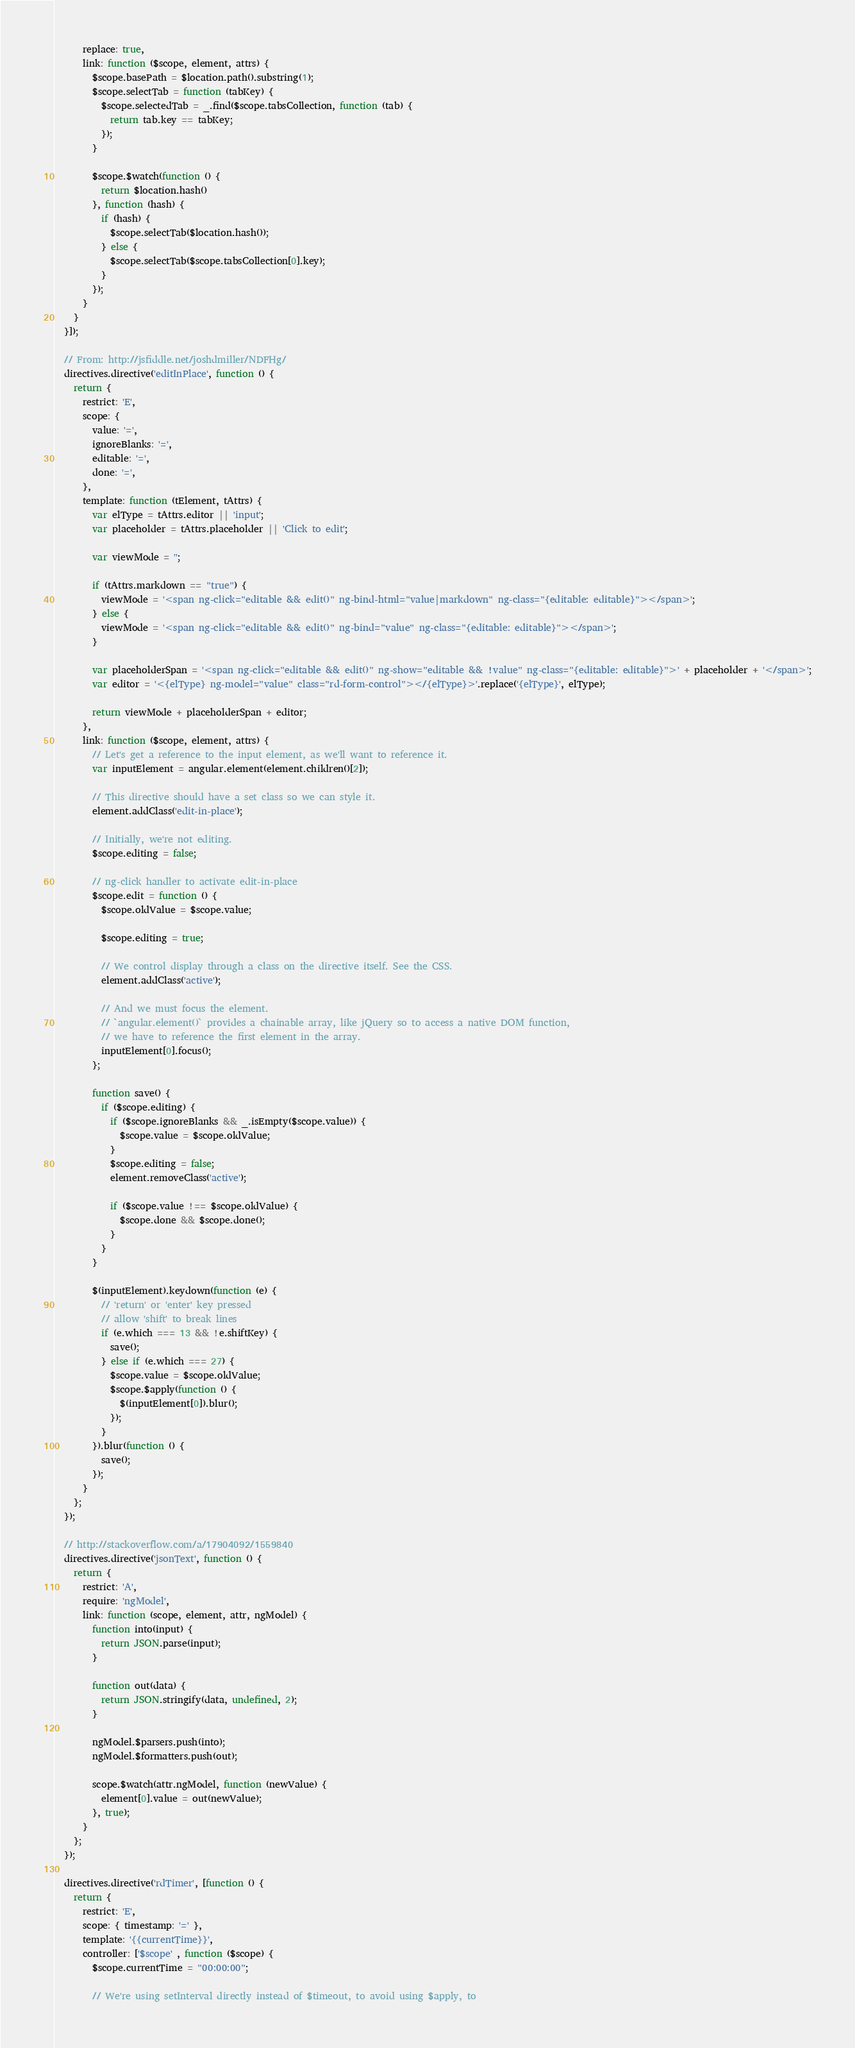<code> <loc_0><loc_0><loc_500><loc_500><_JavaScript_>      replace: true,
      link: function ($scope, element, attrs) {
        $scope.basePath = $location.path().substring(1);
        $scope.selectTab = function (tabKey) {
          $scope.selectedTab = _.find($scope.tabsCollection, function (tab) {
            return tab.key == tabKey;
          });
        }

        $scope.$watch(function () {
          return $location.hash()
        }, function (hash) {
          if (hash) {
            $scope.selectTab($location.hash());
          } else {
            $scope.selectTab($scope.tabsCollection[0].key);
          }
        });
      }
    }
  }]);

  // From: http://jsfiddle.net/joshdmiller/NDFHg/
  directives.directive('editInPlace', function () {
    return {
      restrict: 'E',
      scope: {
        value: '=',
        ignoreBlanks: '=',
        editable: '=',
        done: '=',
      },
      template: function (tElement, tAttrs) {
        var elType = tAttrs.editor || 'input';
        var placeholder = tAttrs.placeholder || 'Click to edit';

        var viewMode = '';

        if (tAttrs.markdown == "true") {
          viewMode = '<span ng-click="editable && edit()" ng-bind-html="value|markdown" ng-class="{editable: editable}"></span>';
        } else {
          viewMode = '<span ng-click="editable && edit()" ng-bind="value" ng-class="{editable: editable}"></span>';
        }

        var placeholderSpan = '<span ng-click="editable && edit()" ng-show="editable && !value" ng-class="{editable: editable}">' + placeholder + '</span>';
        var editor = '<{elType} ng-model="value" class="rd-form-control"></{elType}>'.replace('{elType}', elType);

        return viewMode + placeholderSpan + editor;
      },
      link: function ($scope, element, attrs) {
        // Let's get a reference to the input element, as we'll want to reference it.
        var inputElement = angular.element(element.children()[2]);

        // This directive should have a set class so we can style it.
        element.addClass('edit-in-place');

        // Initially, we're not editing.
        $scope.editing = false;

        // ng-click handler to activate edit-in-place
        $scope.edit = function () {
          $scope.oldValue = $scope.value;

          $scope.editing = true;

          // We control display through a class on the directive itself. See the CSS.
          element.addClass('active');

          // And we must focus the element.
          // `angular.element()` provides a chainable array, like jQuery so to access a native DOM function,
          // we have to reference the first element in the array.
          inputElement[0].focus();
        };

        function save() {
          if ($scope.editing) {
            if ($scope.ignoreBlanks && _.isEmpty($scope.value)) {
              $scope.value = $scope.oldValue;
            }
            $scope.editing = false;
            element.removeClass('active');

            if ($scope.value !== $scope.oldValue) {
              $scope.done && $scope.done();
            }
          }
        }

        $(inputElement).keydown(function (e) {
          // 'return' or 'enter' key pressed
          // allow 'shift' to break lines
          if (e.which === 13 && !e.shiftKey) {
            save();
          } else if (e.which === 27) {
            $scope.value = $scope.oldValue;
            $scope.$apply(function () {
              $(inputElement[0]).blur();
            });
          }
        }).blur(function () {
          save();
        });
      }
    };
  });

  // http://stackoverflow.com/a/17904092/1559840
  directives.directive('jsonText', function () {
    return {
      restrict: 'A',
      require: 'ngModel',
      link: function (scope, element, attr, ngModel) {
        function into(input) {
          return JSON.parse(input);
        }

        function out(data) {
          return JSON.stringify(data, undefined, 2);
        }

        ngModel.$parsers.push(into);
        ngModel.$formatters.push(out);

        scope.$watch(attr.ngModel, function (newValue) {
          element[0].value = out(newValue);
        }, true);
      }
    };
  });

  directives.directive('rdTimer', [function () {
    return {
      restrict: 'E',
      scope: { timestamp: '=' },
      template: '{{currentTime}}',
      controller: ['$scope' , function ($scope) {
        $scope.currentTime = "00:00:00";

        // We're using setInterval directly instead of $timeout, to avoid using $apply, to</code> 